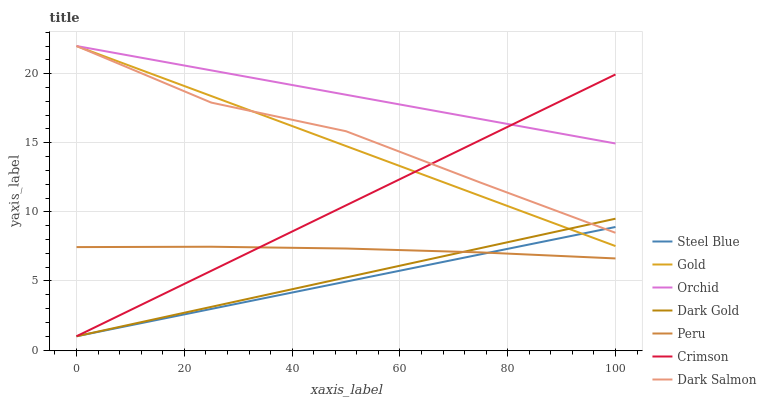Does Steel Blue have the minimum area under the curve?
Answer yes or no. Yes. Does Orchid have the maximum area under the curve?
Answer yes or no. Yes. Does Dark Gold have the minimum area under the curve?
Answer yes or no. No. Does Dark Gold have the maximum area under the curve?
Answer yes or no. No. Is Crimson the smoothest?
Answer yes or no. Yes. Is Dark Salmon the roughest?
Answer yes or no. Yes. Is Dark Gold the smoothest?
Answer yes or no. No. Is Dark Gold the roughest?
Answer yes or no. No. Does Dark Gold have the lowest value?
Answer yes or no. Yes. Does Dark Salmon have the lowest value?
Answer yes or no. No. Does Orchid have the highest value?
Answer yes or no. Yes. Does Dark Gold have the highest value?
Answer yes or no. No. Is Peru less than Dark Salmon?
Answer yes or no. Yes. Is Orchid greater than Steel Blue?
Answer yes or no. Yes. Does Steel Blue intersect Peru?
Answer yes or no. Yes. Is Steel Blue less than Peru?
Answer yes or no. No. Is Steel Blue greater than Peru?
Answer yes or no. No. Does Peru intersect Dark Salmon?
Answer yes or no. No. 